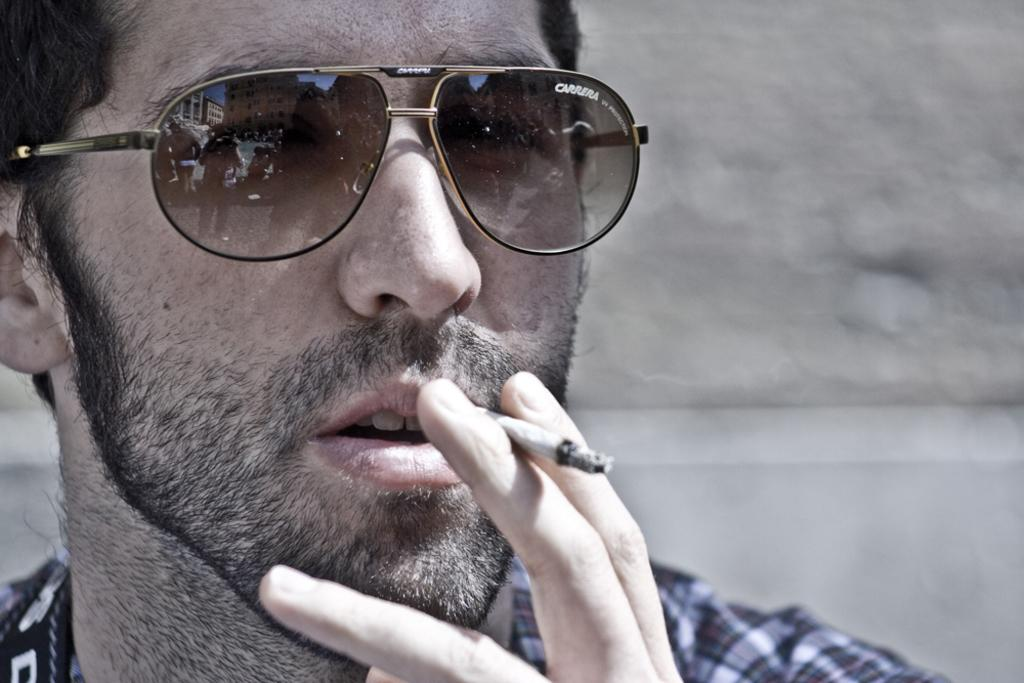What is the appearance of the person in the image who is truncated? The person in the image who is truncated is partially visible, with only a portion of their body shown. What activity is the person in the image who is smoking engaged in? The person in the image who is smoking is holding a cigarette and inhaling the smoke. What accessory is the person in the image who is wearing sunglasses sporting? The person in the image who is wearing sunglasses has a pair of sunglasses on their face. What is the color of the background in the image? The background of the image is white in color. What type of chalk is the person in the image using to write on the board? There is no chalk or board present in the image; it features three people with different appearances and activities. What committee is the person in the image a part of? There is no mention of a committee or any organizational affiliation in the image. 